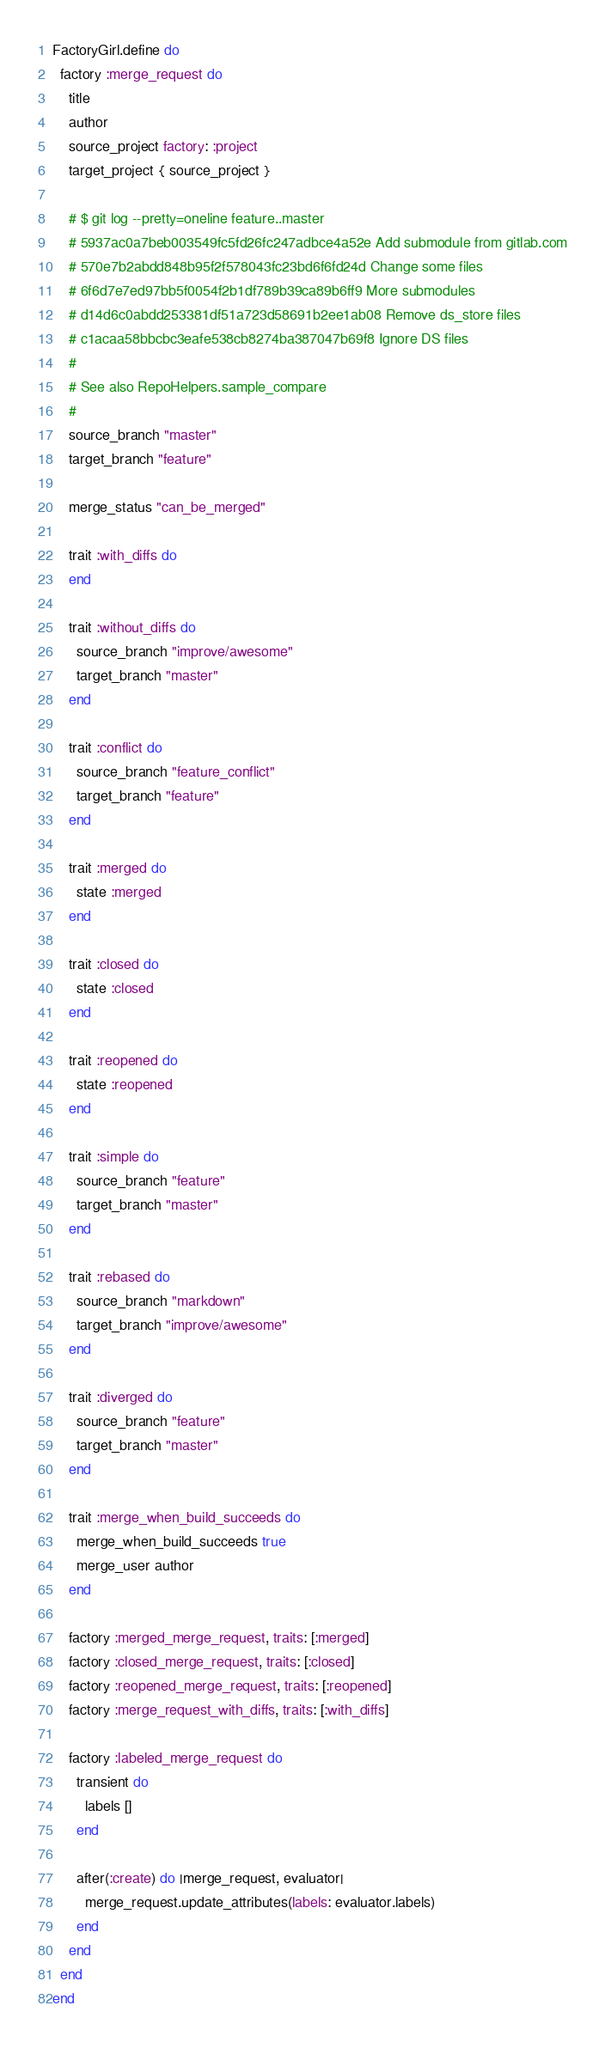<code> <loc_0><loc_0><loc_500><loc_500><_Ruby_>FactoryGirl.define do
  factory :merge_request do
    title
    author
    source_project factory: :project
    target_project { source_project }

    # $ git log --pretty=oneline feature..master
    # 5937ac0a7beb003549fc5fd26fc247adbce4a52e Add submodule from gitlab.com
    # 570e7b2abdd848b95f2f578043fc23bd6f6fd24d Change some files
    # 6f6d7e7ed97bb5f0054f2b1df789b39ca89b6ff9 More submodules
    # d14d6c0abdd253381df51a723d58691b2ee1ab08 Remove ds_store files
    # c1acaa58bbcbc3eafe538cb8274ba387047b69f8 Ignore DS files
    #
    # See also RepoHelpers.sample_compare
    #
    source_branch "master"
    target_branch "feature"

    merge_status "can_be_merged"

    trait :with_diffs do
    end

    trait :without_diffs do
      source_branch "improve/awesome"
      target_branch "master"
    end

    trait :conflict do
      source_branch "feature_conflict"
      target_branch "feature"
    end

    trait :merged do
      state :merged
    end

    trait :closed do
      state :closed
    end

    trait :reopened do
      state :reopened
    end

    trait :simple do
      source_branch "feature"
      target_branch "master"
    end

    trait :rebased do
      source_branch "markdown"
      target_branch "improve/awesome"
    end

    trait :diverged do
      source_branch "feature"
      target_branch "master"
    end

    trait :merge_when_build_succeeds do
      merge_when_build_succeeds true
      merge_user author
    end

    factory :merged_merge_request, traits: [:merged]
    factory :closed_merge_request, traits: [:closed]
    factory :reopened_merge_request, traits: [:reopened]
    factory :merge_request_with_diffs, traits: [:with_diffs]

    factory :labeled_merge_request do
      transient do
        labels []
      end

      after(:create) do |merge_request, evaluator|
        merge_request.update_attributes(labels: evaluator.labels)
      end
    end
  end
end
</code> 